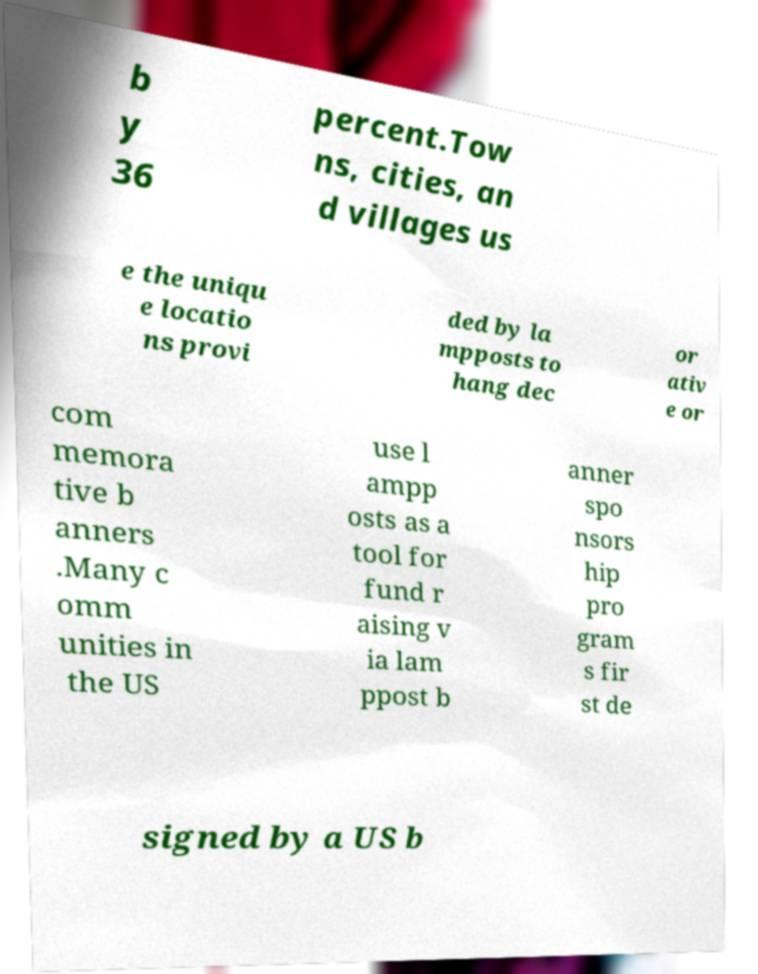Please identify and transcribe the text found in this image. b y 36 percent.Tow ns, cities, an d villages us e the uniqu e locatio ns provi ded by la mpposts to hang dec or ativ e or com memora tive b anners .Many c omm unities in the US use l ampp osts as a tool for fund r aising v ia lam ppost b anner spo nsors hip pro gram s fir st de signed by a US b 